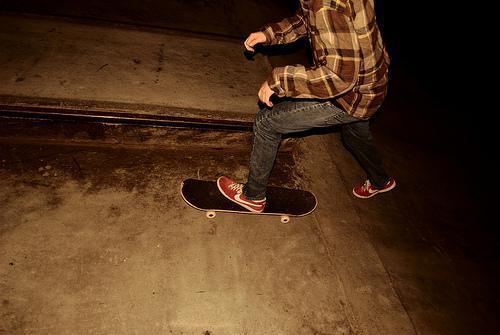How many feet are on the skateboard?
Give a very brief answer. 1. 